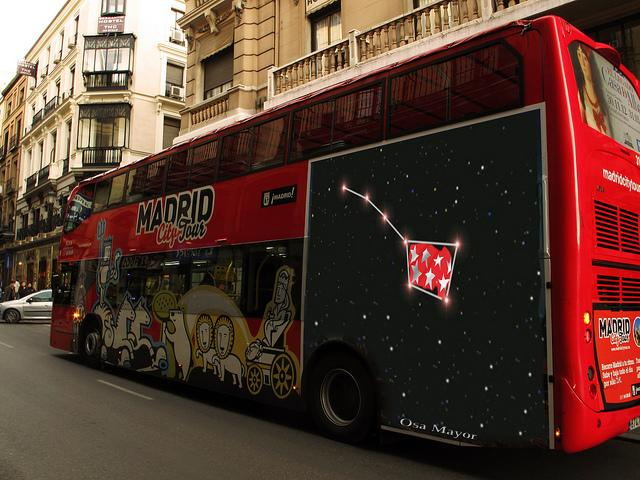What is this constellation often called in English? big dipper 